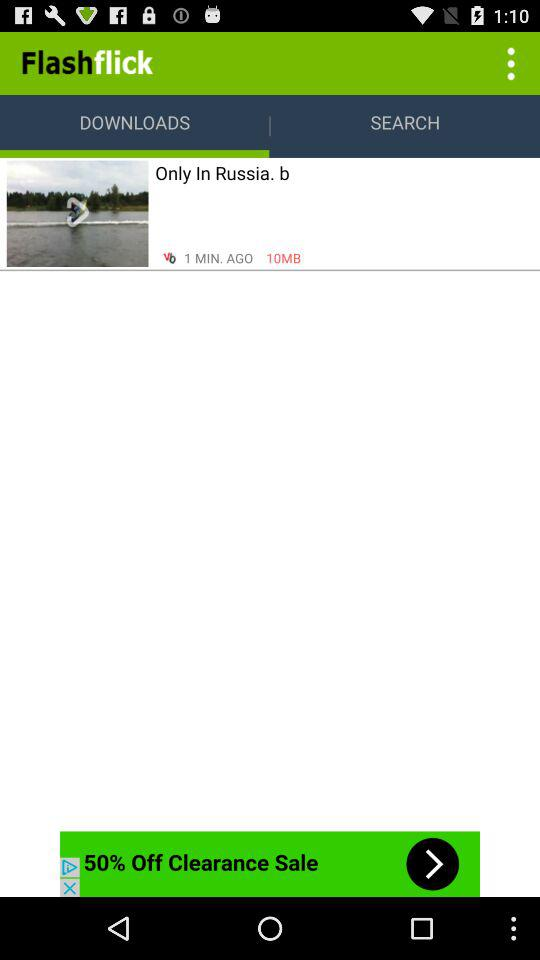What is the file name? The file name is "Only In Russia. b". 